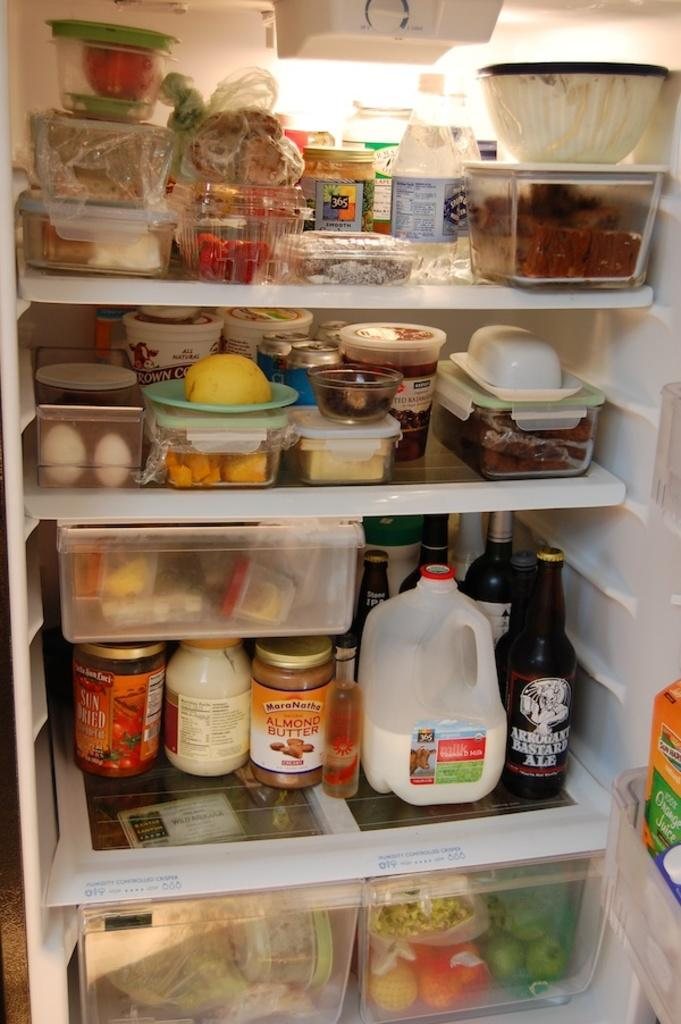<image>
Render a clear and concise summary of the photo. A refridgerator that has milk on the bottom with a bottle of Arrogant Bastard Ale next to it. 